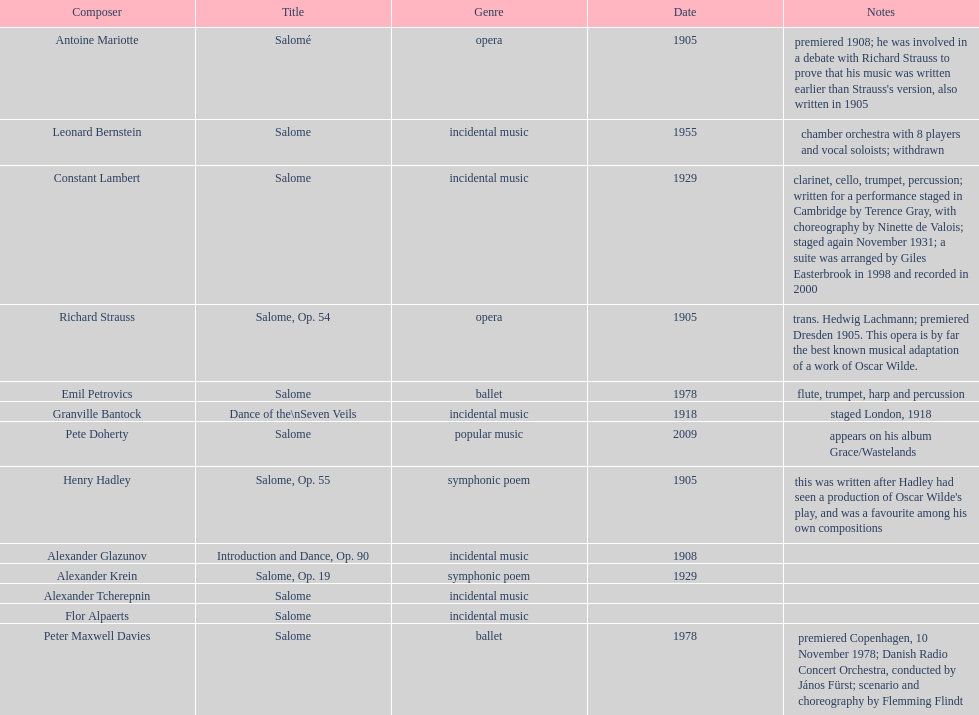What is the difference in years of granville bantock's work compared to pete dohert? 91. 